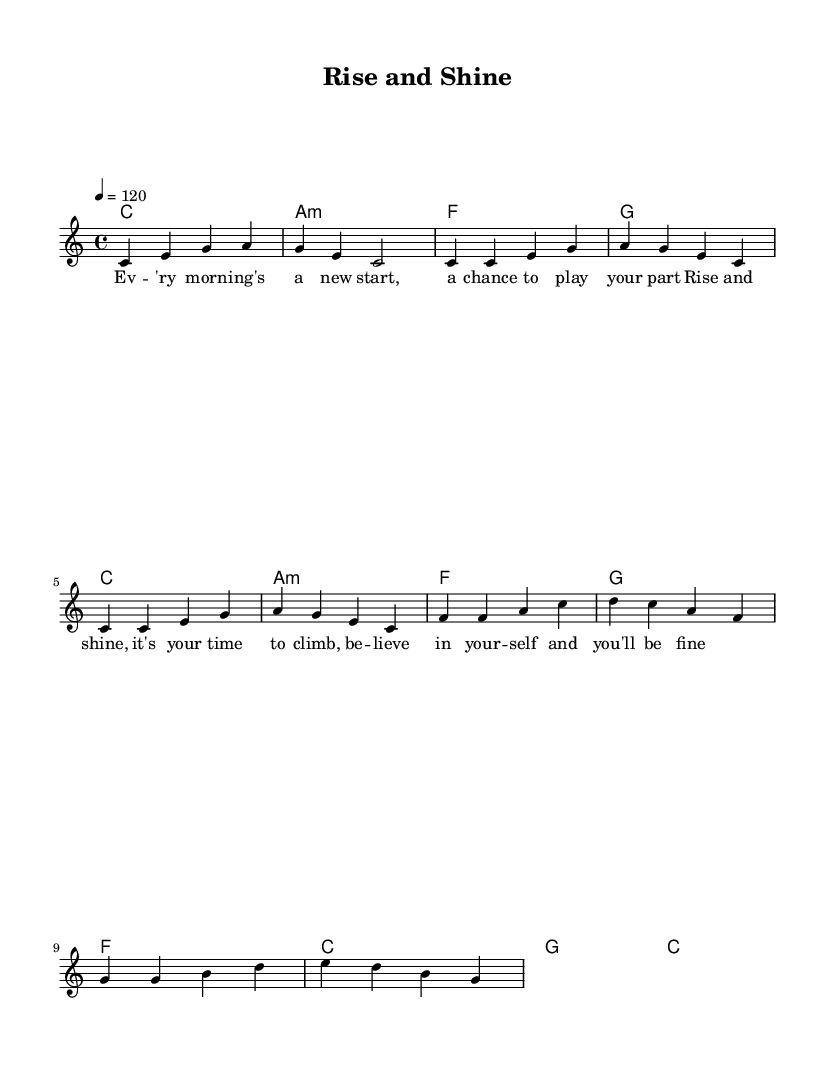What is the key signature of this music? The key signature is indicated in the global context at the beginning of the music and shows that there are no sharps or flats, defining it as C major.
Answer: C major What is the time signature of this music? The time signature is also found in the global context at the outset of the sheet music, which displays a 4 over 4, meaning there are four beats in each measure.
Answer: 4/4 What is the tempo marking for the piece? The tempo is specified at the beginning, which indicates the speed of the music. The marking shows that the tempo should be set to 120 beats per minute.
Answer: 120 How many measures are in the chorus? The chorus section consists of the measures specifically allocated for that part, which, upon counting, shows that there are four measures in the chorus.
Answer: 4 What is the main lyrical theme of the chorus? By examining the lyrics in the chorus, they express encouragement and positivity about self-belief and seizing opportunities, summarizing this as the theme of motivation and affirmation.
Answer: Motivation What chords are used in the verse? The chords can be identified by looking at the chord progression in the harmonies section underneath the verse lyrics, which repeats the same sequence twice: C major, A minor, F major, and G major.
Answer: C, A minor, F, G What kind of mood does this piece of music convey? By analyzing the tempo, key signature, and lyrics, the upbeat tempo combined with positive affirmations creates a lively and encouraging mood, suggesting a sense of hope and determination.
Answer: Upbeat 